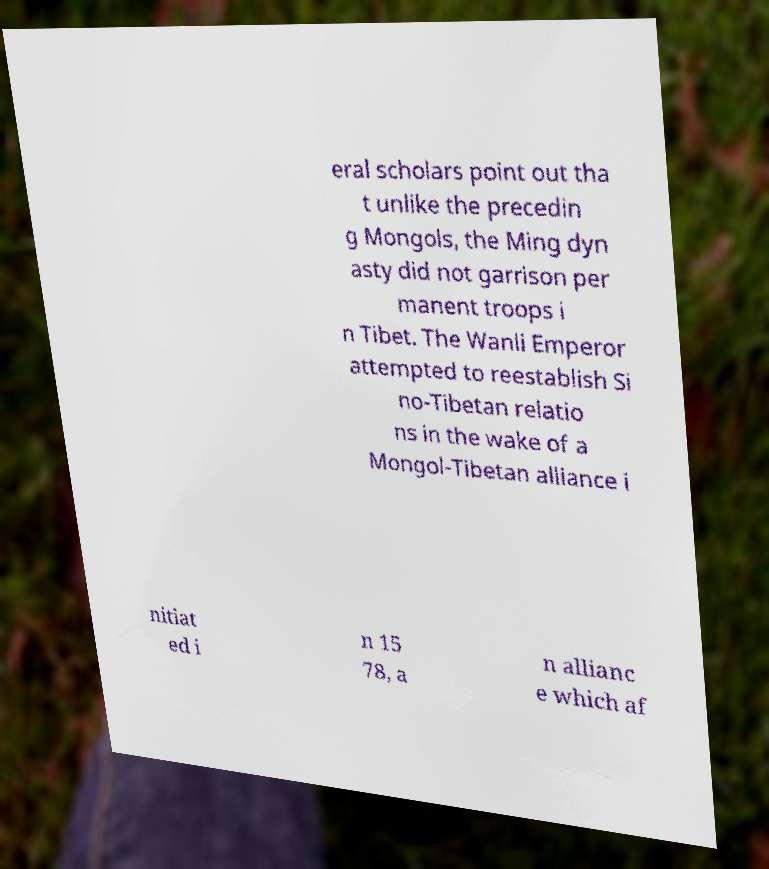I need the written content from this picture converted into text. Can you do that? eral scholars point out tha t unlike the precedin g Mongols, the Ming dyn asty did not garrison per manent troops i n Tibet. The Wanli Emperor attempted to reestablish Si no-Tibetan relatio ns in the wake of a Mongol-Tibetan alliance i nitiat ed i n 15 78, a n allianc e which af 